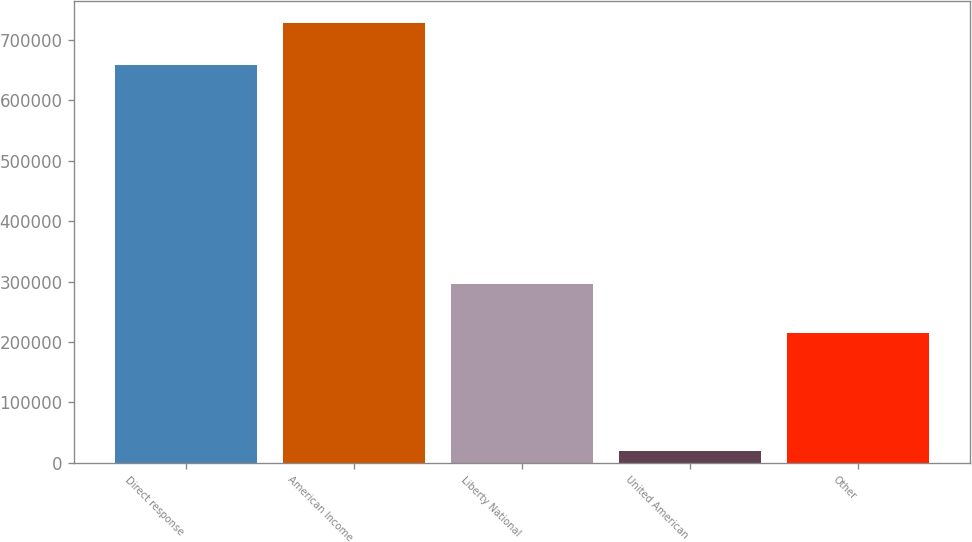Convert chart. <chart><loc_0><loc_0><loc_500><loc_500><bar_chart><fcel>Direct response<fcel>American Income<fcel>Liberty National<fcel>United American<fcel>Other<nl><fcel>659026<fcel>727614<fcel>295396<fcel>19533<fcel>215645<nl></chart> 